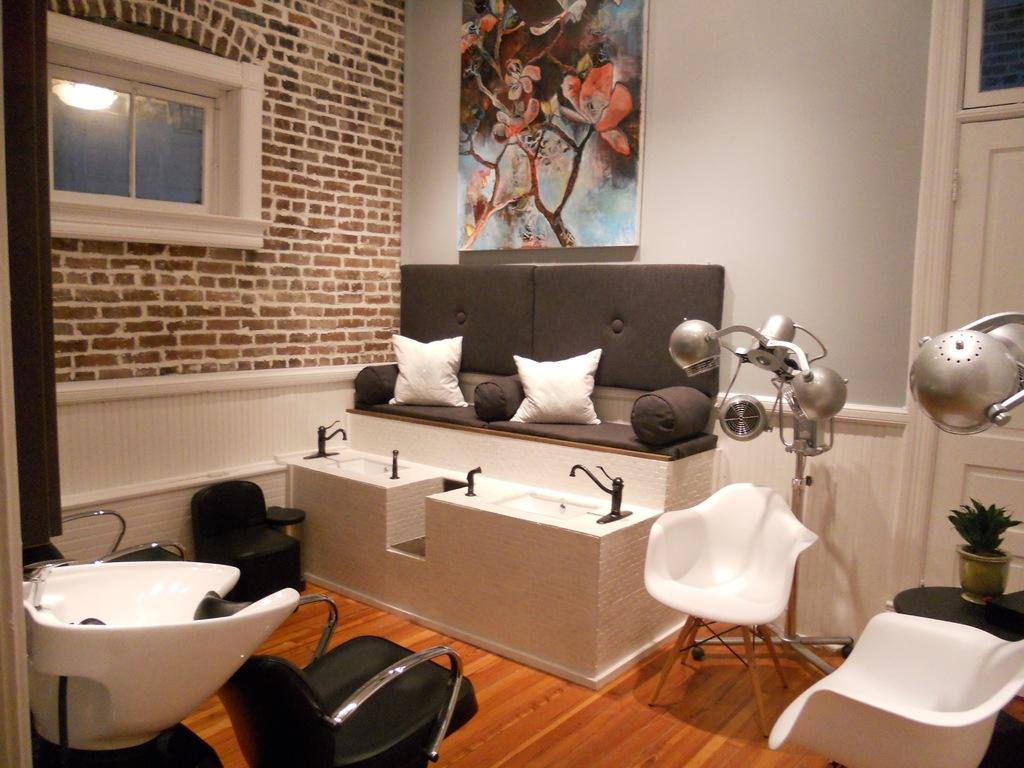What type of furniture is present in the room? There is a couch and a chair in the room. What can be used for decoration or comfort in the room? There is a pillow and a plant in the room. What is the purpose of the tap and wash basin in the room? The tap and wash basin are likely used for washing hands or cleaning purposes. What is the source of natural light in the room? There is a window in the room, which allows natural light to enter. What is attached to the wall in the room? There is a frame attached to the wall. How many clams are sitting on the couch in the room? There are no clams present in the room; the image only shows a couch, chair, pillow, plant, tap, wash basin, window, and frame. 